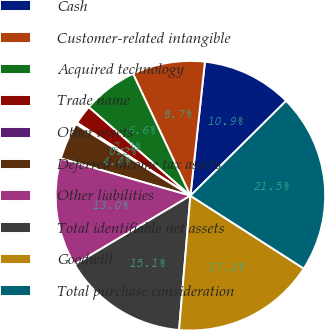Convert chart. <chart><loc_0><loc_0><loc_500><loc_500><pie_chart><fcel>Cash<fcel>Customer-related intangible<fcel>Acquired technology<fcel>Trade name<fcel>Other assets<fcel>Deferred income tax assets<fcel>Other liabilities<fcel>Total identifiable net assets<fcel>Goodwill<fcel>Total purchase consideration<nl><fcel>10.85%<fcel>8.72%<fcel>6.59%<fcel>2.32%<fcel>0.19%<fcel>4.45%<fcel>12.99%<fcel>15.12%<fcel>17.25%<fcel>21.52%<nl></chart> 